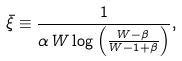Convert formula to latex. <formula><loc_0><loc_0><loc_500><loc_500>\bar { \xi } \equiv \frac { 1 } { \alpha \, W \log \left ( \frac { W - \beta } { W - 1 + \beta } \right ) } ,</formula> 